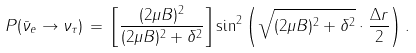Convert formula to latex. <formula><loc_0><loc_0><loc_500><loc_500>P ( \bar { \nu } _ { e } \rightarrow \nu _ { \tau } ) \, = \, \left [ \frac { ( 2 \mu B ) ^ { 2 } } { ( 2 \mu B ) ^ { 2 } + \delta ^ { 2 } } \right ] \sin ^ { 2 } \left ( \sqrt { ( 2 \mu B ) ^ { 2 } + \delta ^ { 2 } } \cdot \frac { \Delta r } { 2 } \right ) .</formula> 